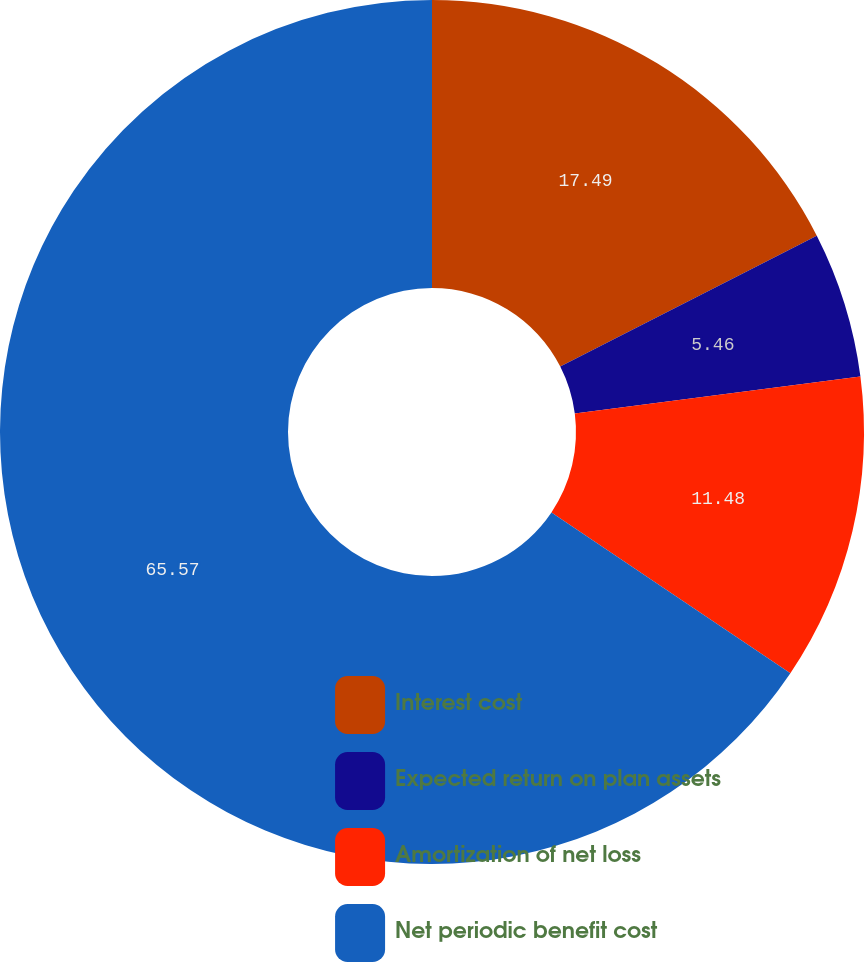Convert chart. <chart><loc_0><loc_0><loc_500><loc_500><pie_chart><fcel>Interest cost<fcel>Expected return on plan assets<fcel>Amortization of net loss<fcel>Net periodic benefit cost<nl><fcel>17.49%<fcel>5.46%<fcel>11.48%<fcel>65.57%<nl></chart> 